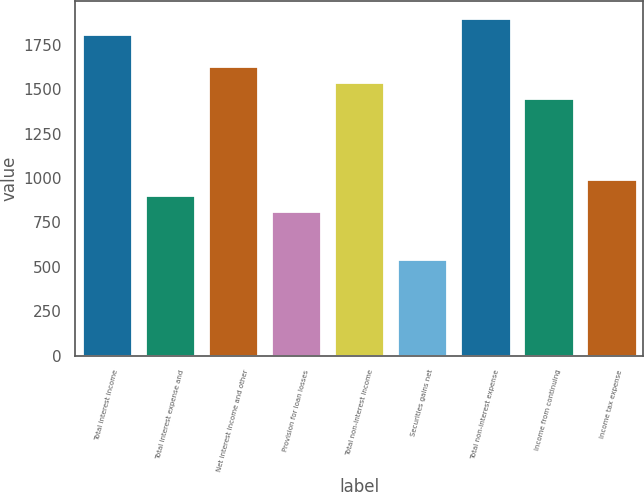Convert chart. <chart><loc_0><loc_0><loc_500><loc_500><bar_chart><fcel>Total interest income<fcel>Total interest expense and<fcel>Net interest income and other<fcel>Provision for loan losses<fcel>Total non-interest income<fcel>Securities gains net<fcel>Total non-interest expense<fcel>Income from continuing<fcel>Income tax expense<nl><fcel>1809.99<fcel>905.01<fcel>1628.99<fcel>814.52<fcel>1538.49<fcel>543.05<fcel>1900.49<fcel>1447.99<fcel>995.5<nl></chart> 